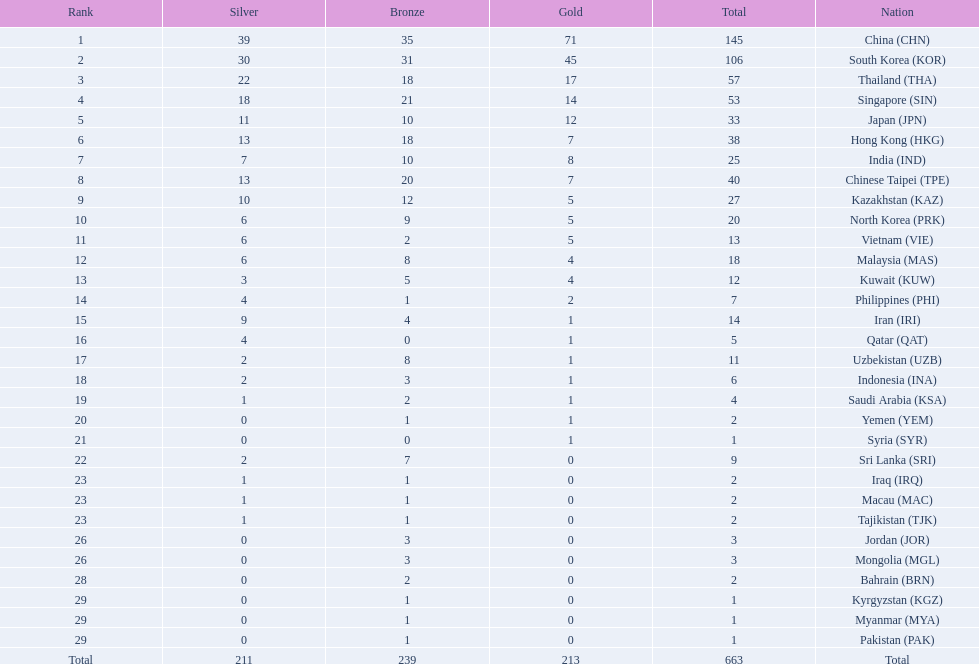How many countries have at least 10 gold medals in the asian youth games? 5. 